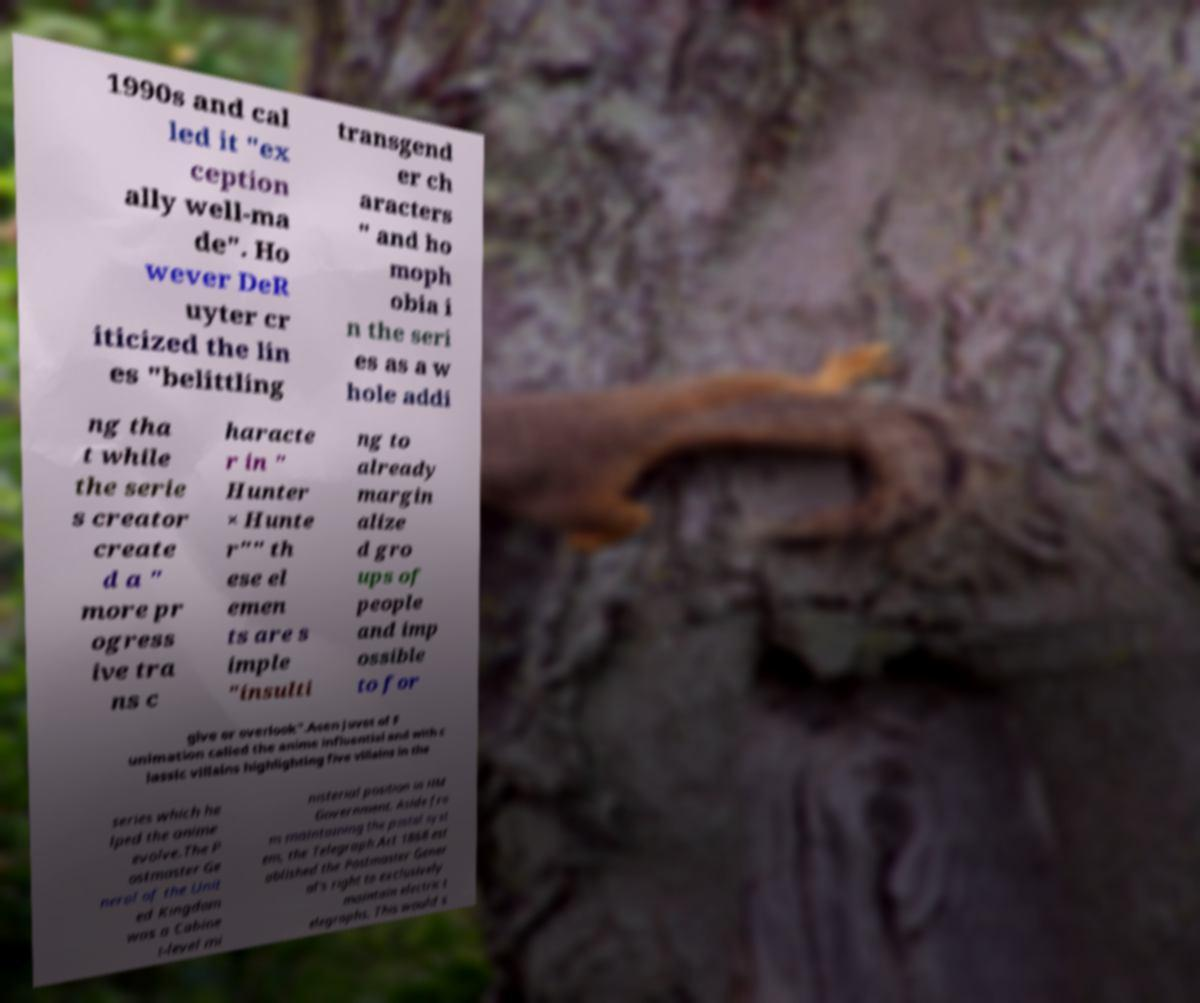I need the written content from this picture converted into text. Can you do that? 1990s and cal led it "ex ception ally well-ma de". Ho wever DeR uyter cr iticized the lin es "belittling transgend er ch aracters " and ho moph obia i n the seri es as a w hole addi ng tha t while the serie s creator create d a " more pr ogress ive tra ns c haracte r in " Hunter × Hunte r"" th ese el emen ts are s imple "insulti ng to already margin alize d gro ups of people and imp ossible to for give or overlook".Aeen Juvet of F unimation called the anime influential and with c lassic villains highlighting five villains in the series which he lped the anime evolve.The P ostmaster Ge neral of the Unit ed Kingdom was a Cabine t-level mi nisterial position in HM Government. Aside fro m maintaining the postal syst em, the Telegraph Act 1868 est ablished the Postmaster Gener al's right to exclusively maintain electric t elegraphs. This would s 